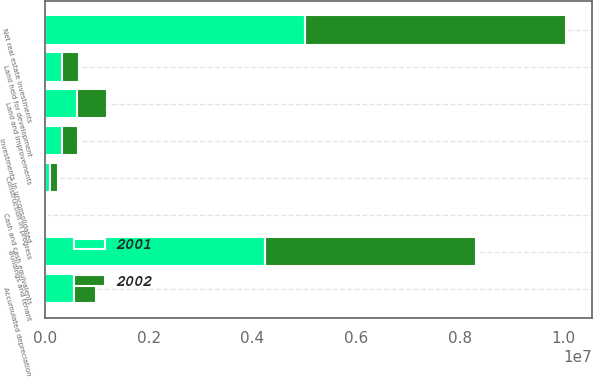Convert chart to OTSL. <chart><loc_0><loc_0><loc_500><loc_500><stacked_bar_chart><ecel><fcel>Land and improvements<fcel>Buildings and tenant<fcel>Construction in progress<fcel>Investments in unconsolidated<fcel>Land held for development<fcel>Accumulated depreciation<fcel>Net real estate investments<fcel>Cash and cash equivalents<nl><fcel>2001<fcel>608995<fcel>4.23736e+06<fcel>85756<fcel>315589<fcel>326535<fcel>555858<fcel>5.01838e+06<fcel>17414<nl><fcel>2002<fcel>583909<fcel>4.06894e+06<fcel>154086<fcel>323682<fcel>322528<fcel>425721<fcel>5.02743e+06<fcel>9483<nl></chart> 